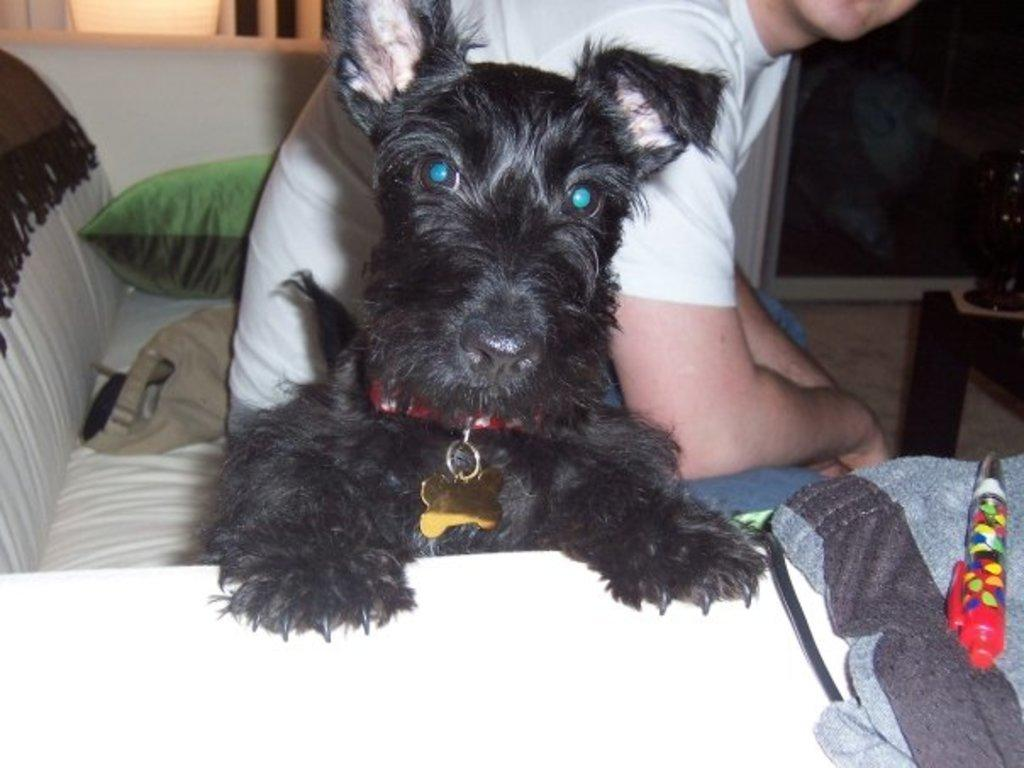What type of animal is in the image? There is a dog in the image. Who else is present in the image? There is a man in the image. What is the man doing in the image? The man is seated on a sofa. Can you describe an object on the right side of the image? There is a pen on the right side of the image. What type of bottle can be seen in the hospital room in the image? There is no hospital room or bottle present in the image. 